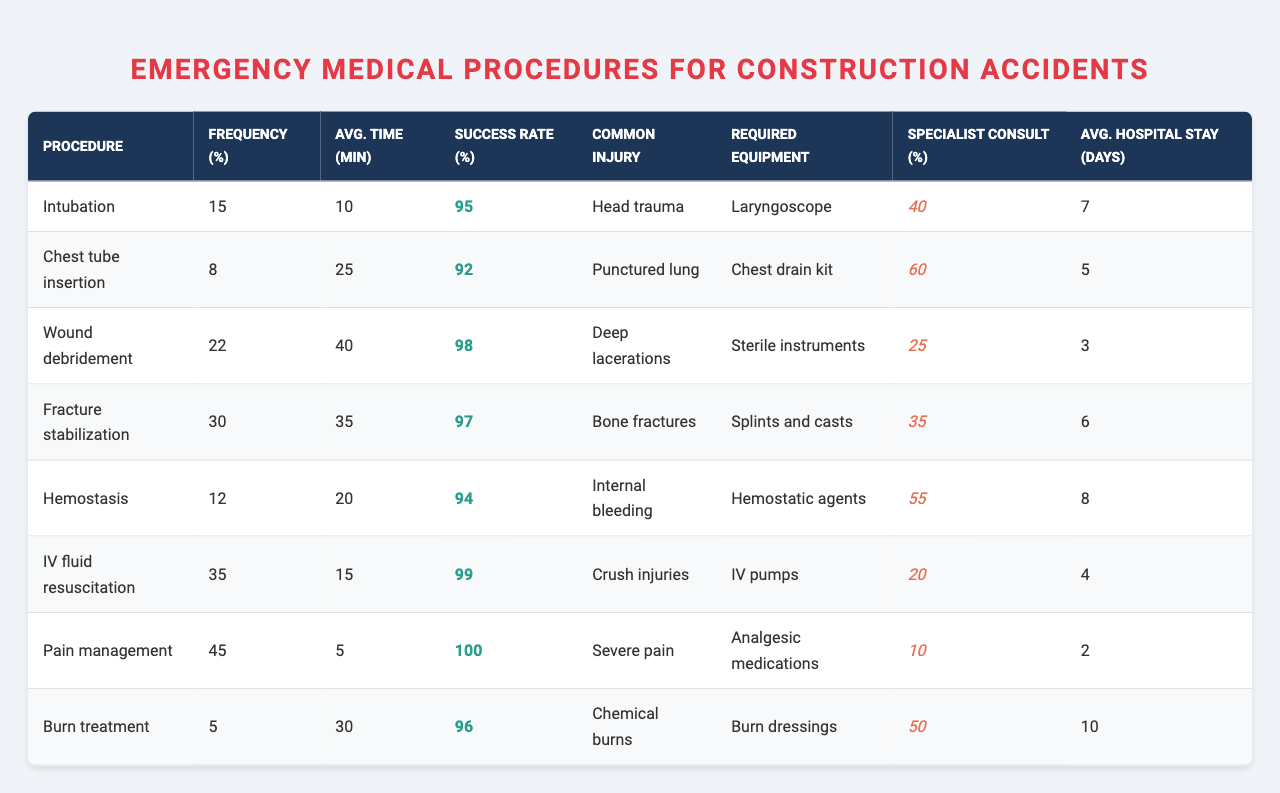What is the most frequently performed emergency procedure? The "Frequency (%)" column shows the percentages for each procedure. The highest percentage is for "Pain management" at 45%.
Answer: Pain management Which emergency procedure has the longest average time to perform? Looking at the "Avg. Time (min)" column, "Wound debridement" has the longest time at 40 minutes.
Answer: Wound debridement What is the success rate for fracture stabilization? The "Success Rate (%)" for "Fracture stabilization" is located in its respective row, which is 97%.
Answer: 97% How many procedures have a success rate above 95%? Checking the "Success Rate (%)" column, the procedures with rates above 95% are: Intubation (95%), Wound debridement (98%), Fracture stabilization (97%), Hemostasis (94%), IV fluid resuscitation (99%), Pain management (100%), and Burn treatment (96%). This counts to 7 procedures.
Answer: 7 What is the average hospital stay for chest tube insertion? The "Avg. Hospital Stay (days)" column indicates that the stay for "Chest tube insertion" is 5 days.
Answer: 5 days What is the average time taken for all procedures? To find the average time, sum the "Avg. Time (min)" values (10 + 25 + 40 + 35 + 20 + 15 + 5 + 30 = 180) and divide by the number of procedures (8). So, 180 / 8 = 22.5 minutes.
Answer: 22.5 minutes Is the success rate for chemical burns less than 95%? The success rate for "Burn treatment," which corresponds to chemical burns, is 96%, which is not less than 95%.
Answer: No Which equipment is most commonly required for procedures focusing on hemostasis? The "Required Equipment" for "Hemostasis" is "Hemostatic agents," identified simply in its row in the table.
Answer: Hemostatic agents How does the average hospital stay for fracture stabilization compare to pain management? "Fracture stabilization" has an average stay of 6 days and "Pain management" has 2 days. The difference is 6 - 2 = 4 days.
Answer: 4 days What percentage of procedures require a specialist consult for severe pain management? The "Specialist Consult (%)" for "Pain management" is listed as 10%.
Answer: 10% 